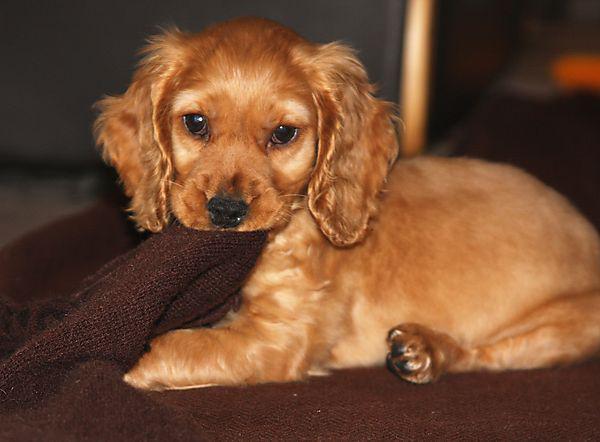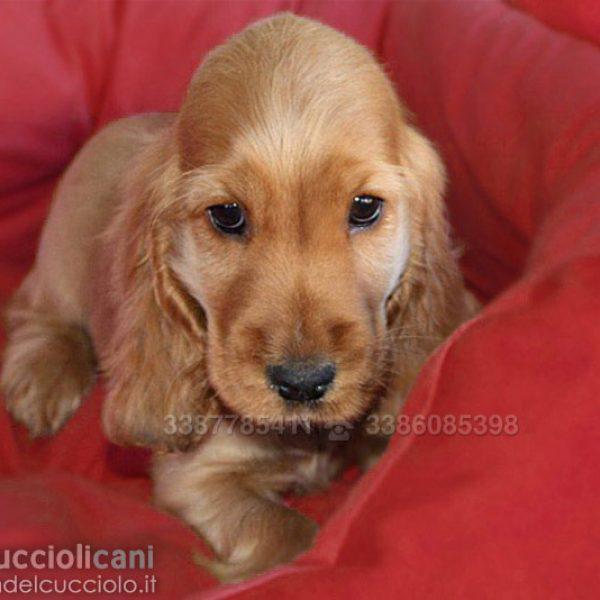The first image is the image on the left, the second image is the image on the right. Assess this claim about the two images: "A spaniel dog is chewing on some object in one of the images.". Correct or not? Answer yes or no. Yes. 